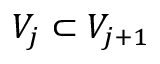Convert formula to latex. <formula><loc_0><loc_0><loc_500><loc_500>V _ { j } \subset V _ { j + 1 }</formula> 